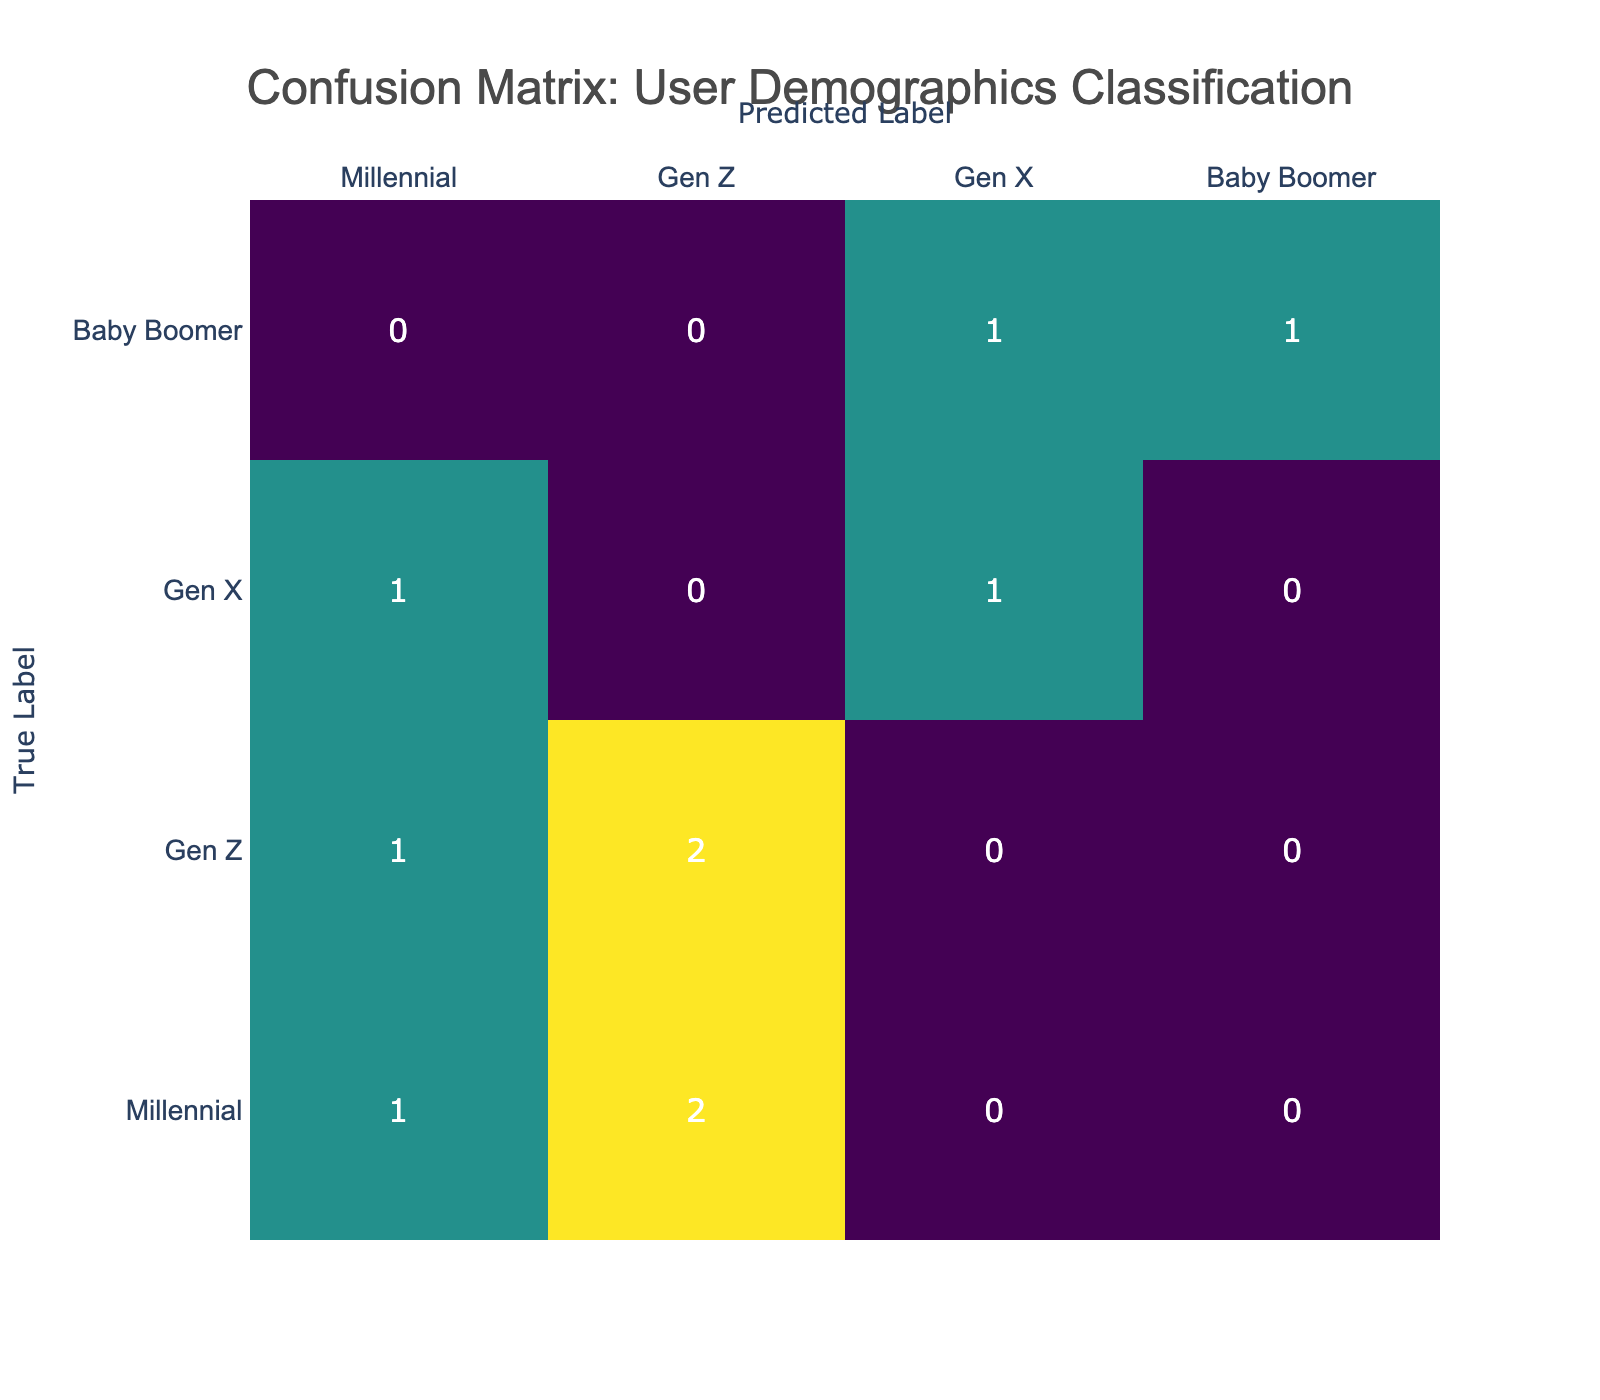What is the predicted label for the true label 'Gen X'? For the true label 'Gen X', the predicted label is 'Gen X' in one instance, while it was also predicted as 'Millennial' once. The data shows a count of 2 for 'Gen X' correctly predicted and 1 misclassification.
Answer: Gen X How many users were classified as Baby Boomers correctly? The count for 'Baby Boomer' as a true label and predicted label is 1, which indicates the number of users correctly classified as Baby Boomers.
Answer: 1 Which age group has the highest misclassification rate? The age group '18-34' shows multiple misclassifications: 2 Millennials predicted as Gen Z, and 1 Gen Z predicted as Millennial. Combining these indicates a high misclassification rate.
Answer: 18-34 What is the total number of instances predicted as 'Millennial'? To find this, sum the instances predicted as 'Millennial' across all true labels: from Gen Z there is 1, and from Gen X there is 1, plus 2 instances correctly predicted which gives a total count of 4.
Answer: 4 Is 'Baby Boomer' ever incorrectly classified as another group? Looking at the data, 'Baby Boomer' was only correctly classified once and not misclassified into any other group. Thus, the answer is no.
Answer: No What is the difference between the number of correct predictions for Gen Z and Gen X? Counting the correct predictions, Gen Z has 2 (for Gen Z correctly predicted) while Gen X has 2 as well; thus, the absolute difference is 0.
Answer: 0 How many total misclassifications were made? By summing the off-diagonal values within the confusion matrix, there are 5 misclassifications: 1 (Millennial as Gen Z) + 1 (Gen Z as Millennial) + 1 (Gen X as Millennial) + 1 (Baby Boomer as Gen X) + 1 (Millennial as Gen Z) = 5.
Answer: 5 Which group had the highest number of overall classifications? Checking the sums of each row, 'Millennial' had a total of 5 predictions, making it the group with the highest number of classifications.
Answer: Millennial 